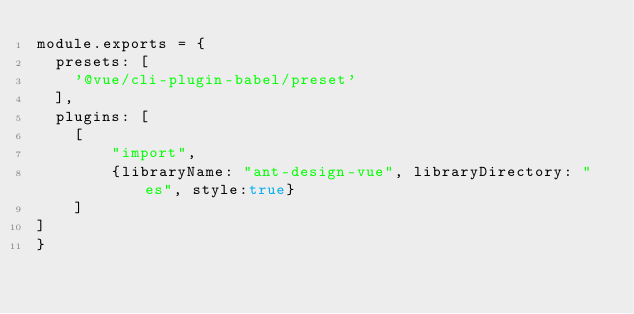Convert code to text. <code><loc_0><loc_0><loc_500><loc_500><_JavaScript_>module.exports = {
  presets: [
    '@vue/cli-plugin-babel/preset'
  ],
  plugins: [
    [
        "import",
        {libraryName: "ant-design-vue", libraryDirectory: "es", style:true}
    ]
]
}
</code> 